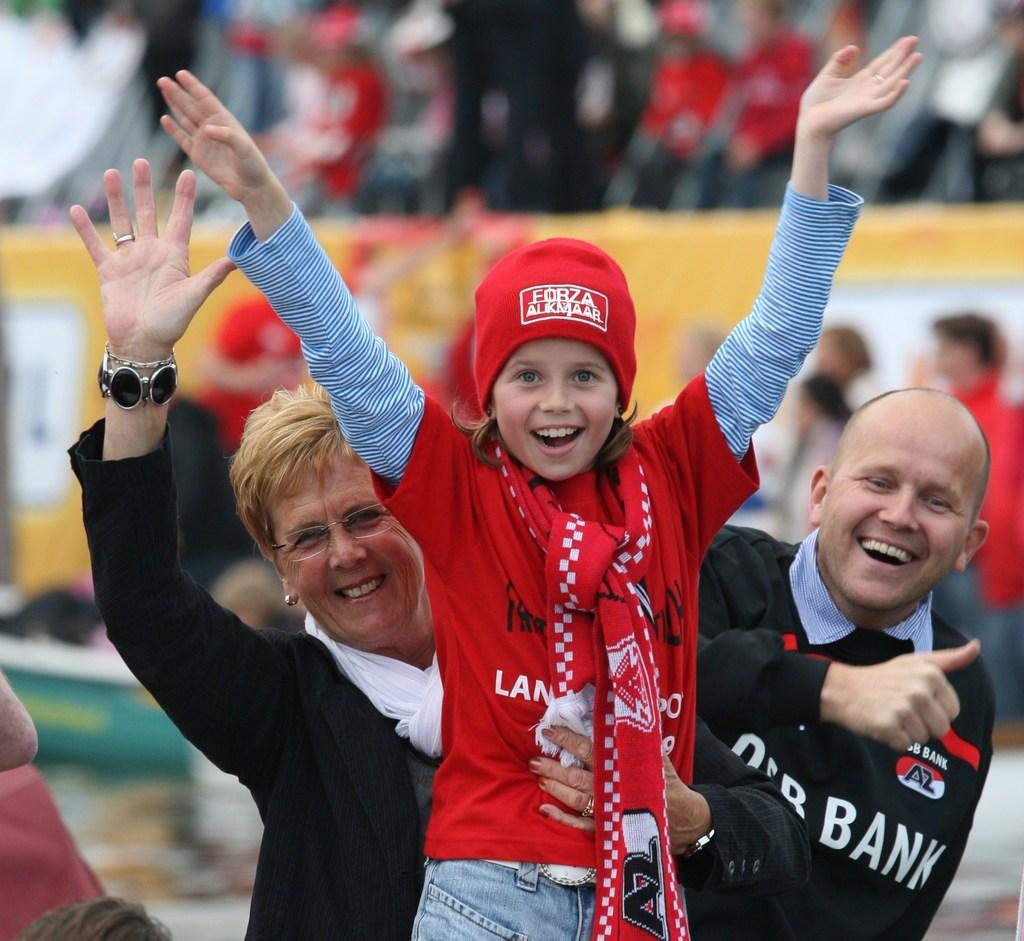How many people are in the image? There are three people in the image. What is the facial expression of the people in the image? The three people are smiling. Can you describe what is happening in the background of the image? There is a group of people in the background of the image, and there are objects visible as well. How would you describe the clarity of the background in the image? The background of the image is blurry. Can you hear the owl hooting in the image? There is no owl present in the image, so it is not possible to hear it hooting. 